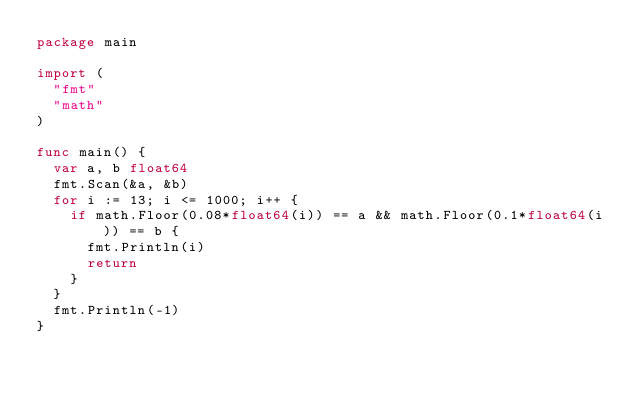Convert code to text. <code><loc_0><loc_0><loc_500><loc_500><_Go_>package main

import (
	"fmt"
	"math"
)

func main() {
	var a, b float64
	fmt.Scan(&a, &b)
	for i := 13; i <= 1000; i++ {
		if math.Floor(0.08*float64(i)) == a && math.Floor(0.1*float64(i)) == b {
			fmt.Println(i)
			return
		}
	}
	fmt.Println(-1)
}
</code> 